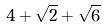<formula> <loc_0><loc_0><loc_500><loc_500>4 + \sqrt { 2 } + \sqrt { 6 }</formula> 